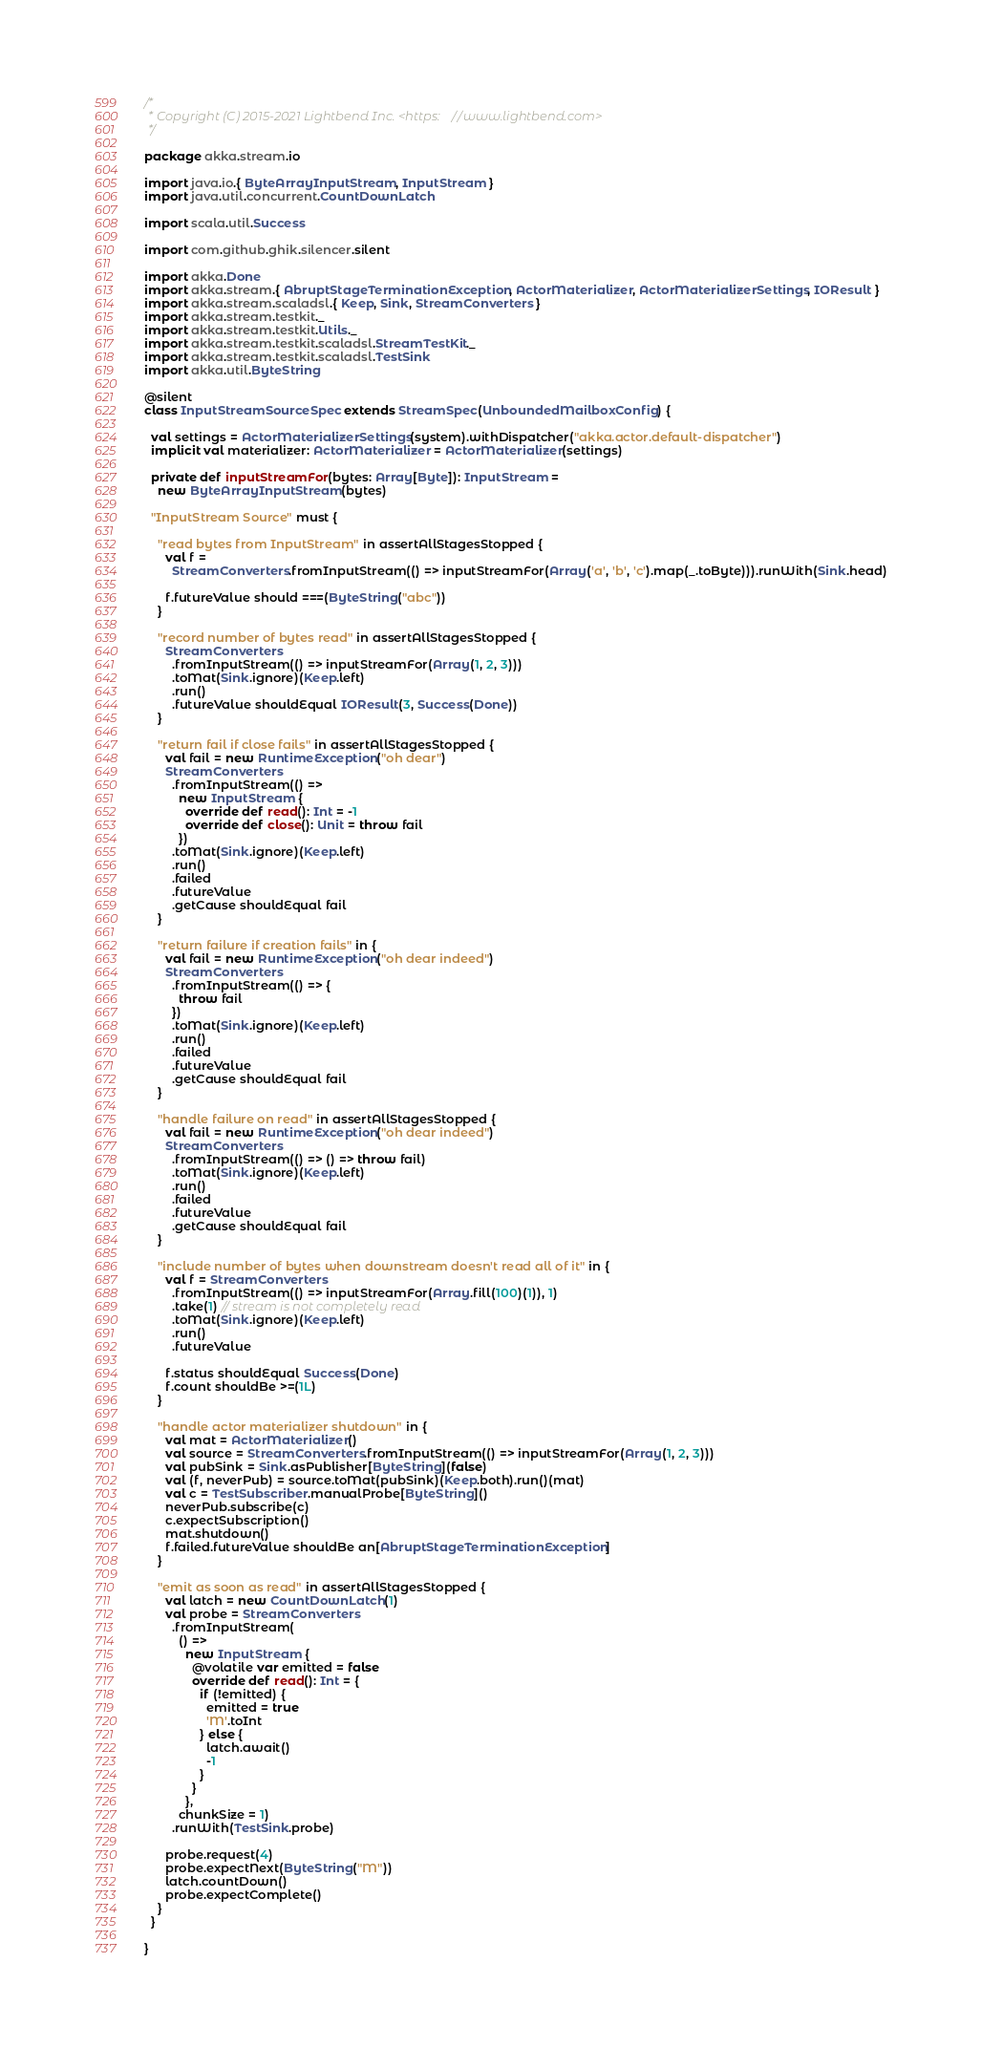Convert code to text. <code><loc_0><loc_0><loc_500><loc_500><_Scala_>/*
 * Copyright (C) 2015-2021 Lightbend Inc. <https://www.lightbend.com>
 */

package akka.stream.io

import java.io.{ ByteArrayInputStream, InputStream }
import java.util.concurrent.CountDownLatch

import scala.util.Success

import com.github.ghik.silencer.silent

import akka.Done
import akka.stream.{ AbruptStageTerminationException, ActorMaterializer, ActorMaterializerSettings, IOResult }
import akka.stream.scaladsl.{ Keep, Sink, StreamConverters }
import akka.stream.testkit._
import akka.stream.testkit.Utils._
import akka.stream.testkit.scaladsl.StreamTestKit._
import akka.stream.testkit.scaladsl.TestSink
import akka.util.ByteString

@silent
class InputStreamSourceSpec extends StreamSpec(UnboundedMailboxConfig) {

  val settings = ActorMaterializerSettings(system).withDispatcher("akka.actor.default-dispatcher")
  implicit val materializer: ActorMaterializer = ActorMaterializer(settings)

  private def inputStreamFor(bytes: Array[Byte]): InputStream =
    new ByteArrayInputStream(bytes)

  "InputStream Source" must {

    "read bytes from InputStream" in assertAllStagesStopped {
      val f =
        StreamConverters.fromInputStream(() => inputStreamFor(Array('a', 'b', 'c').map(_.toByte))).runWith(Sink.head)

      f.futureValue should ===(ByteString("abc"))
    }

    "record number of bytes read" in assertAllStagesStopped {
      StreamConverters
        .fromInputStream(() => inputStreamFor(Array(1, 2, 3)))
        .toMat(Sink.ignore)(Keep.left)
        .run()
        .futureValue shouldEqual IOResult(3, Success(Done))
    }

    "return fail if close fails" in assertAllStagesStopped {
      val fail = new RuntimeException("oh dear")
      StreamConverters
        .fromInputStream(() =>
          new InputStream {
            override def read(): Int = -1
            override def close(): Unit = throw fail
          })
        .toMat(Sink.ignore)(Keep.left)
        .run()
        .failed
        .futureValue
        .getCause shouldEqual fail
    }

    "return failure if creation fails" in {
      val fail = new RuntimeException("oh dear indeed")
      StreamConverters
        .fromInputStream(() => {
          throw fail
        })
        .toMat(Sink.ignore)(Keep.left)
        .run()
        .failed
        .futureValue
        .getCause shouldEqual fail
    }

    "handle failure on read" in assertAllStagesStopped {
      val fail = new RuntimeException("oh dear indeed")
      StreamConverters
        .fromInputStream(() => () => throw fail)
        .toMat(Sink.ignore)(Keep.left)
        .run()
        .failed
        .futureValue
        .getCause shouldEqual fail
    }

    "include number of bytes when downstream doesn't read all of it" in {
      val f = StreamConverters
        .fromInputStream(() => inputStreamFor(Array.fill(100)(1)), 1)
        .take(1) // stream is not completely read
        .toMat(Sink.ignore)(Keep.left)
        .run()
        .futureValue

      f.status shouldEqual Success(Done)
      f.count shouldBe >=(1L)
    }

    "handle actor materializer shutdown" in {
      val mat = ActorMaterializer()
      val source = StreamConverters.fromInputStream(() => inputStreamFor(Array(1, 2, 3)))
      val pubSink = Sink.asPublisher[ByteString](false)
      val (f, neverPub) = source.toMat(pubSink)(Keep.both).run()(mat)
      val c = TestSubscriber.manualProbe[ByteString]()
      neverPub.subscribe(c)
      c.expectSubscription()
      mat.shutdown()
      f.failed.futureValue shouldBe an[AbruptStageTerminationException]
    }

    "emit as soon as read" in assertAllStagesStopped {
      val latch = new CountDownLatch(1)
      val probe = StreamConverters
        .fromInputStream(
          () =>
            new InputStream {
              @volatile var emitted = false
              override def read(): Int = {
                if (!emitted) {
                  emitted = true
                  'M'.toInt
                } else {
                  latch.await()
                  -1
                }
              }
            },
          chunkSize = 1)
        .runWith(TestSink.probe)

      probe.request(4)
      probe.expectNext(ByteString("M"))
      latch.countDown()
      probe.expectComplete()
    }
  }

}
</code> 